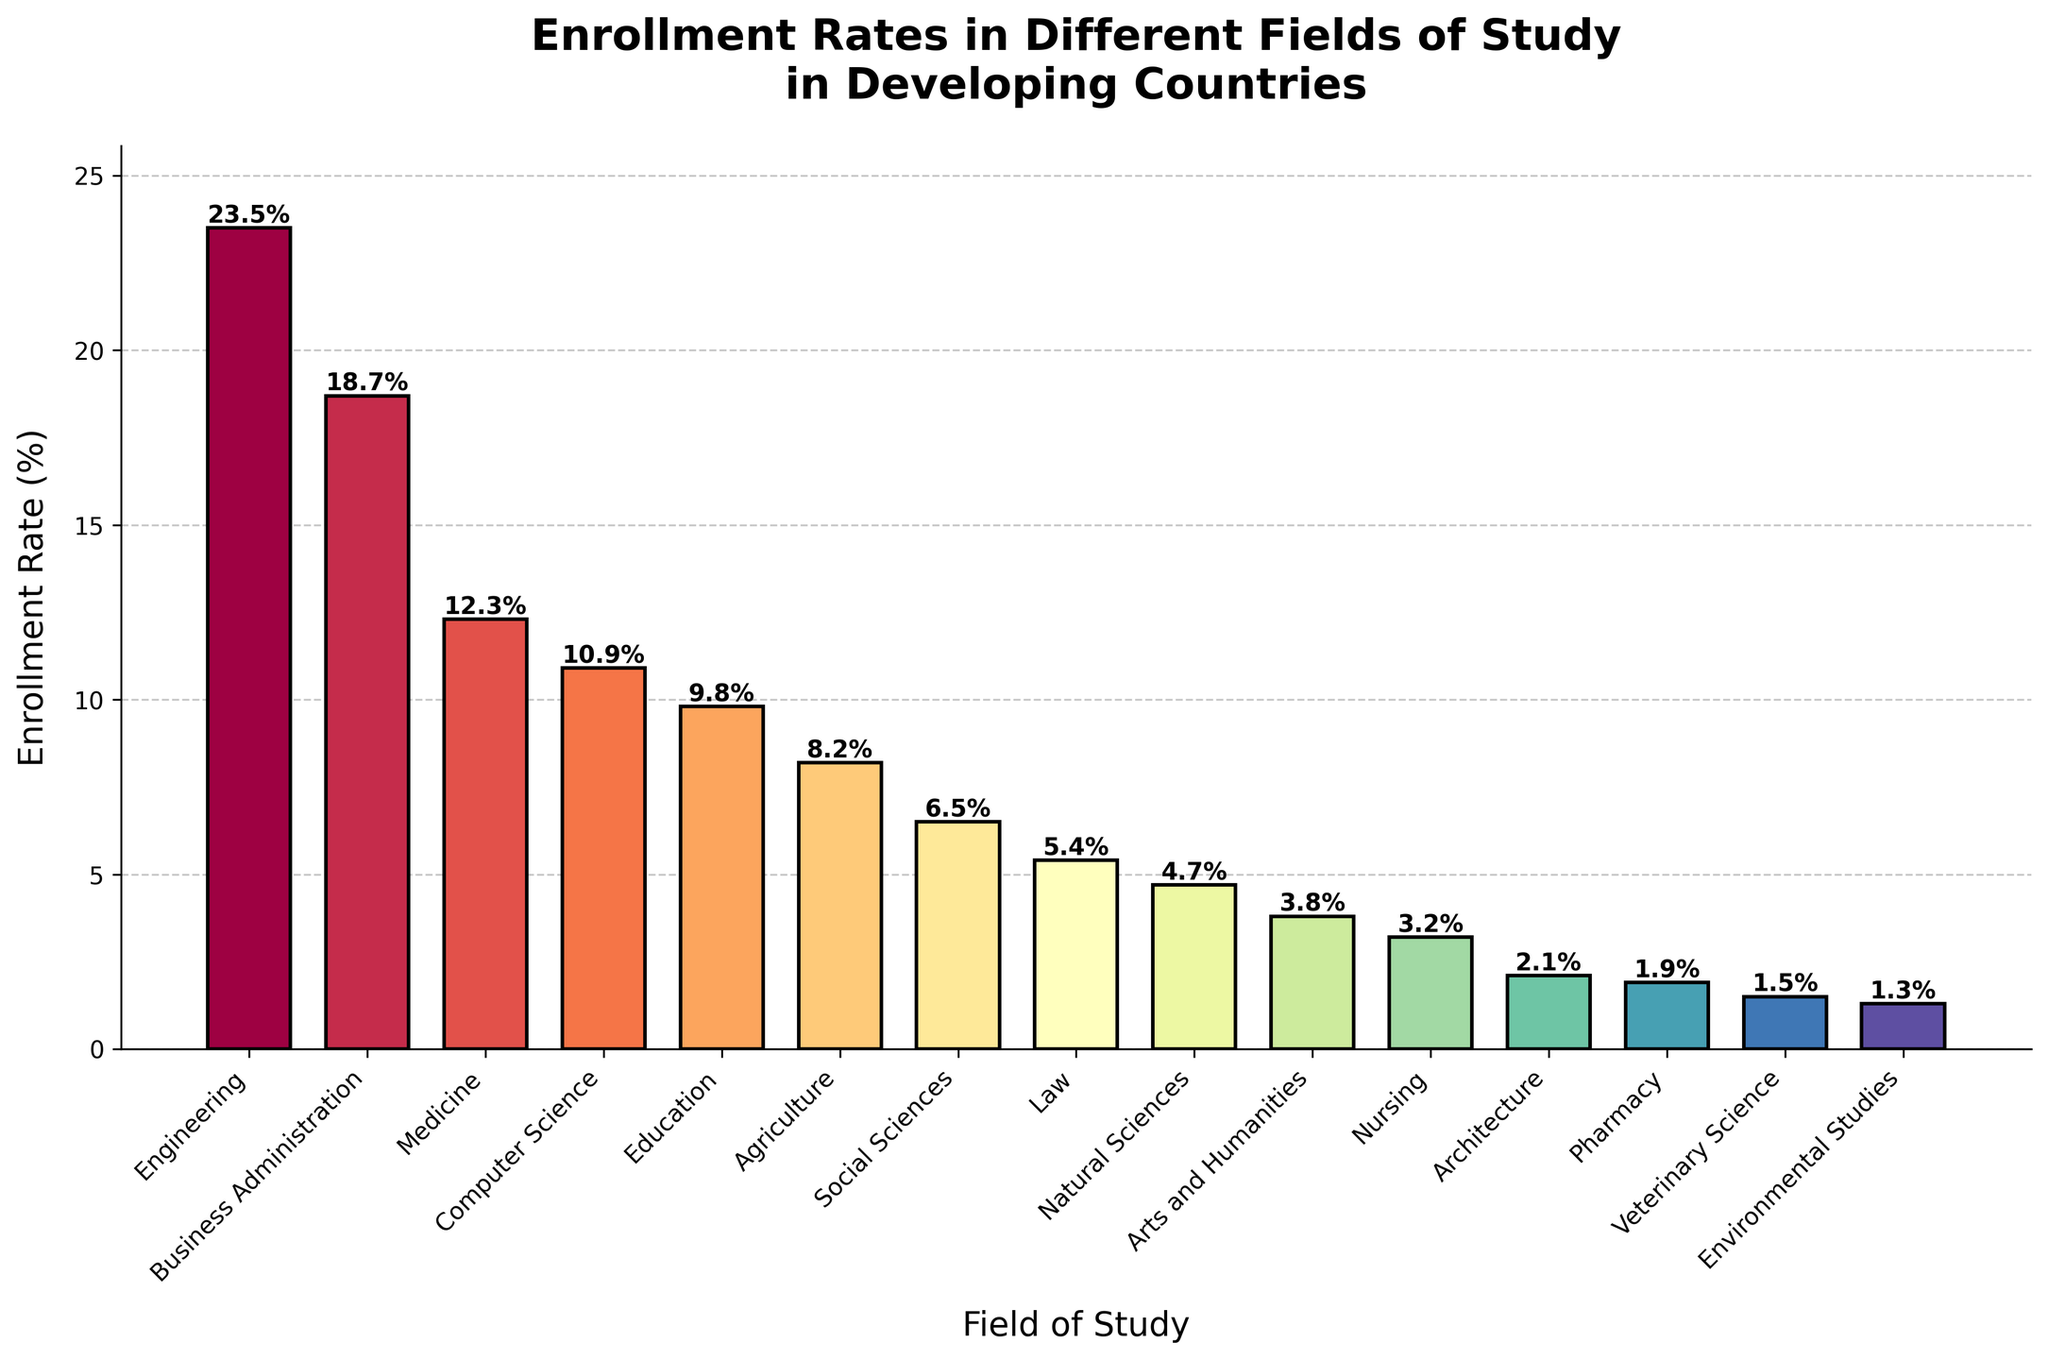What is the field of study with the highest enrollment rate? To determine the field with the highest enrollment rate, look for the bar that is the tallest in the chart. The tallest bar indicates the field of study with 23.5%.
Answer: Engineering Which field has a lower enrollment rate: Medicine or Computer Science? Locate the bars for Medicine and Computer Science. Medicine has an enrollment rate of 12.3%, and Computer Science has an enrollment rate of 10.9%. Since 10.9% is lower than 12.3%, Computer Science has a lower rate.
Answer: Computer Science What is the sum of the enrollment rates for Education and Agriculture? Identify the bars for Education and Agriculture. Education has a rate of 9.8%, and Agriculture has a rate of 8.2%. The sum is calculated as 9.8% + 8.2% = 18.
Answer: 18 What are the enrollment rates for fields where the rate is less than 5%? Scan the chart to locate fields with bars shorter than the 5% mark. The fields are Natural Sciences (4.7%), Arts and Humanities (3.8%), Nursing (3.2%), Architecture (2.1%), Pharmacy (1.9%), Veterinary Science (1.5%), and Environmental Studies (1.3%).
Answer: Natural Sciences: 4.7%, Arts and Humanities: 3.8%, Nursing: 3.2%, Architecture: 2.1%, Pharmacy: 1.9%, Veterinary Science: 1.5%, Environmental Studies: 1.3% Which two fields have the closest enrollment rates? Identify bars with very similar heights. Business Administration (18.7%) and Medicine (12.3%) are not close, but Education (9.8%) and Computer Science (10.9%) are very near to each other with a difference of 1.1%.
Answer: Education and Computer Science Calculate the average enrollment rate for Law, Social Sciences, and Nursing. Find the bars for Law (5.4%), Social Sciences (6.5%), and Nursing (3.2%). Average is calculated as (5.4 + 6.5 + 3.2) / 3 = 15.1 / 3 ≈ 5.03.
Answer: 5.03 Which field’s bar is the second tallest? The tallest bar is for Engineering. Look for the next tallest. Business Administration at 18.7% is the second tallest after Engineering.
Answer: Business Administration What is the difference in enrollment rates between Architecture and Pharmacy? Locate the bars for Architecture (2.1%) and Pharmacy (1.9%). Calculate the difference as 2.1% - 1.9% = 0.2%.
Answer: 0.2 Which two fields have the lowest enrollment rates? Identify the bars shortest in height. The two shortest bars correspond to Veterinary Science (1.5%) and Environmental Studies (1.3%).
Answer: Veterinary Science and Environmental Studies Estimate the midpoint enrollment rate for all listed fields. List all rates: 23.5, 18.7, 12.3, 10.9, 9.8, 8.2, 6.5, 5.4, 4.7, 3.8, 3.2, 2.1, 1.9, 1.5, 1.3. The median value, the 8th in the sorted list (1.3, 1.5, 1.9, 2.1, 3.2, 3.8, 4.7, 5.4, 6.5, 8.2, 9.8, 10.9, 12.3, 18.7, 23.5), is 5.4%.
Answer: 5.4 